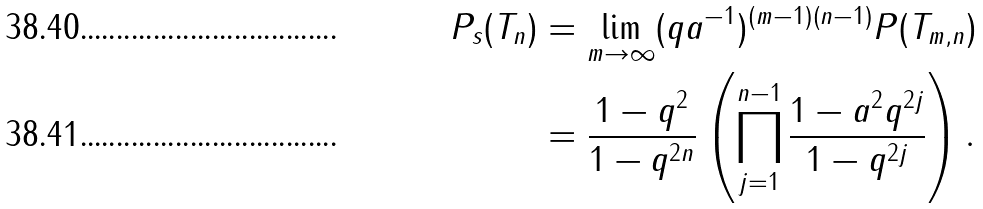<formula> <loc_0><loc_0><loc_500><loc_500>P _ { s } ( T _ { n } ) & = \lim _ { m \to \infty } ( q a ^ { - 1 } ) ^ { ( m - 1 ) ( n - 1 ) } P ( T _ { m , n } ) \\ & = \frac { 1 - q ^ { 2 } } { 1 - q ^ { 2 n } } \left ( \prod _ { j = 1 } ^ { n - 1 } \frac { 1 - a ^ { 2 } q ^ { 2 j } } { 1 - q ^ { 2 j } } \right ) .</formula> 